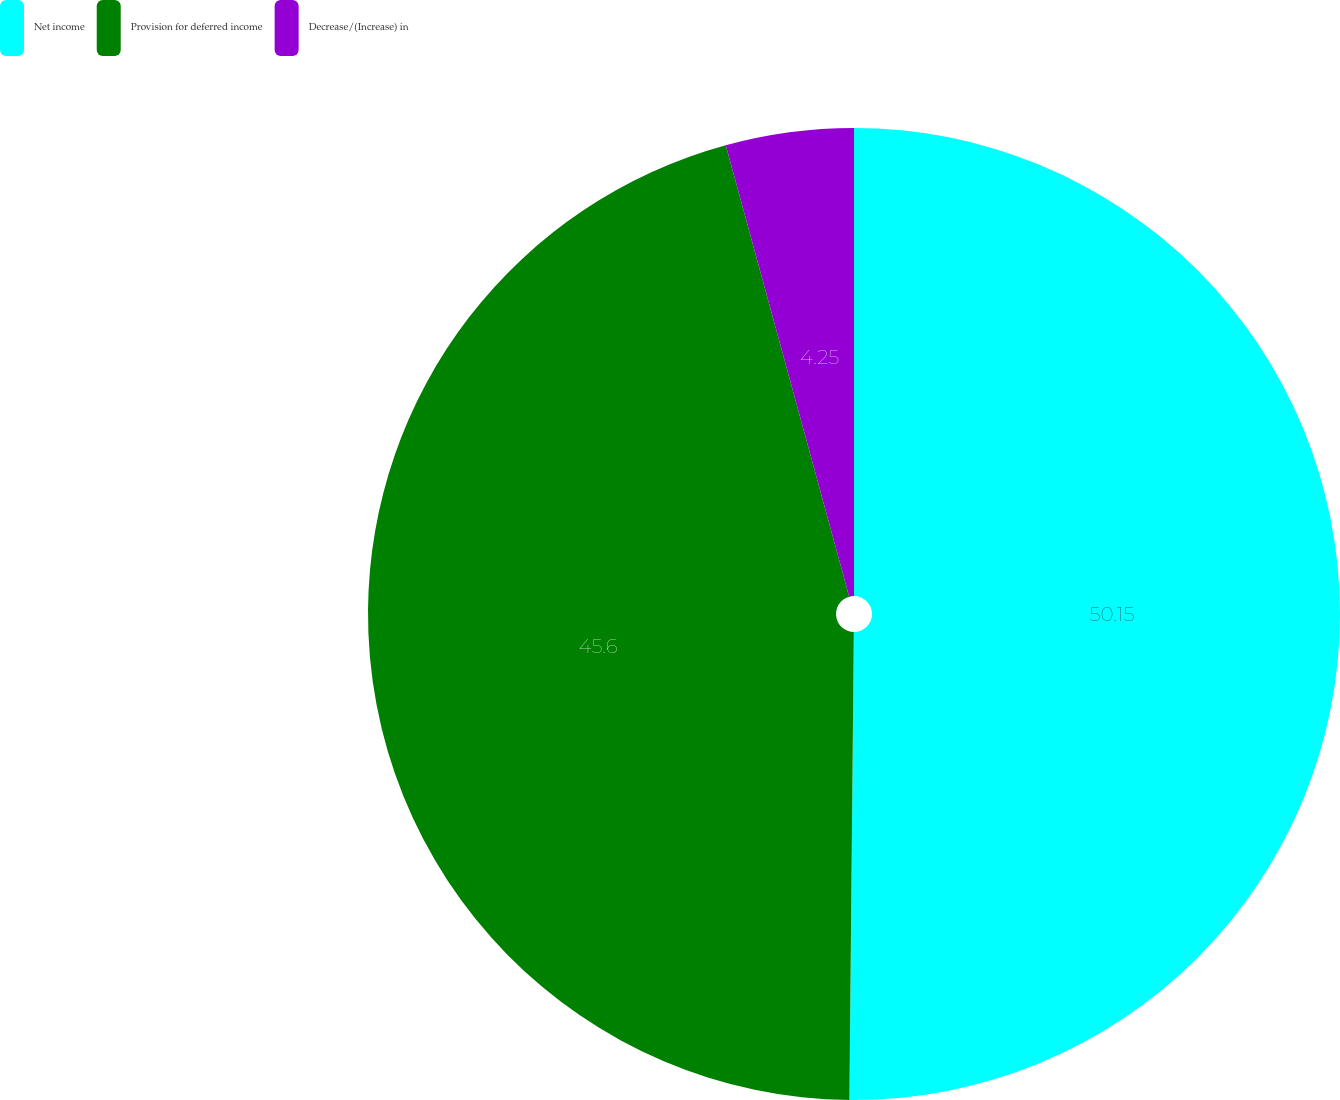<chart> <loc_0><loc_0><loc_500><loc_500><pie_chart><fcel>Net income<fcel>Provision for deferred income<fcel>Decrease/(Increase) in<nl><fcel>50.15%<fcel>45.6%<fcel>4.25%<nl></chart> 